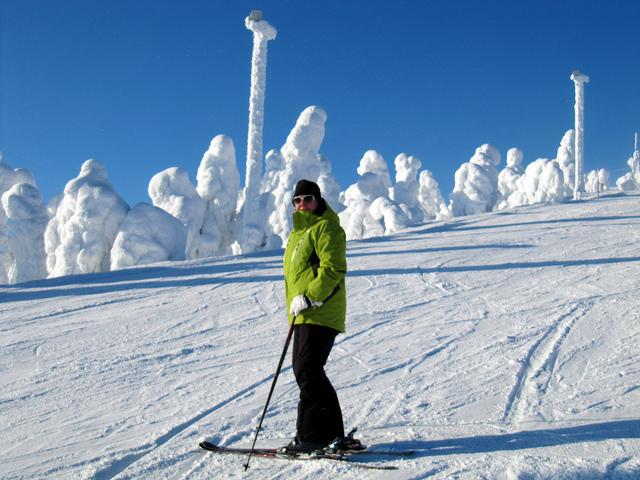Is this a professional skier?
Be succinct. No. Do you think it's cold in this photo?
Be succinct. Yes. Is there snow?
Be succinct. Yes. 